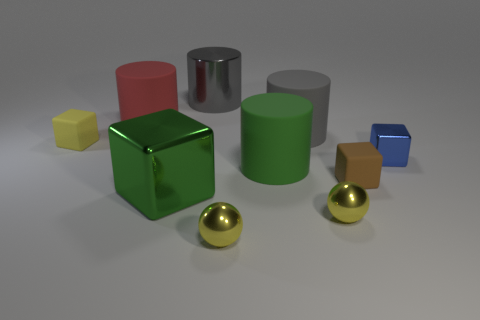Subtract all cubes. How many objects are left? 6 Add 2 spheres. How many spheres are left? 4 Add 3 large green matte cylinders. How many large green matte cylinders exist? 4 Subtract 1 red cylinders. How many objects are left? 9 Subtract all matte objects. Subtract all large cylinders. How many objects are left? 1 